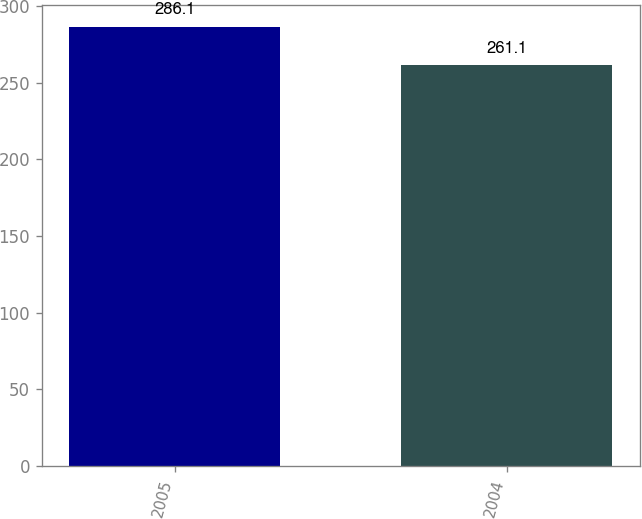Convert chart to OTSL. <chart><loc_0><loc_0><loc_500><loc_500><bar_chart><fcel>2005<fcel>2004<nl><fcel>286.1<fcel>261.1<nl></chart> 